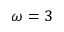Convert formula to latex. <formula><loc_0><loc_0><loc_500><loc_500>\omega = 3</formula> 